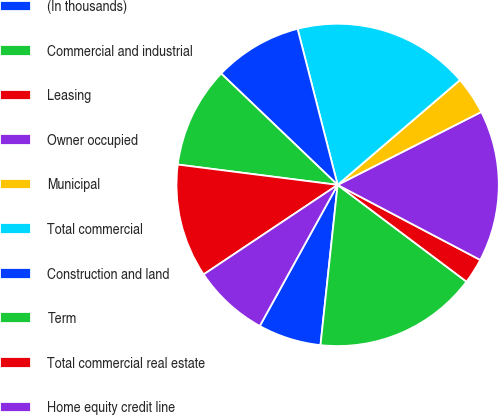Convert chart to OTSL. <chart><loc_0><loc_0><loc_500><loc_500><pie_chart><fcel>(In thousands)<fcel>Commercial and industrial<fcel>Leasing<fcel>Owner occupied<fcel>Municipal<fcel>Total commercial<fcel>Construction and land<fcel>Term<fcel>Total commercial real estate<fcel>Home equity credit line<nl><fcel>6.33%<fcel>16.45%<fcel>2.54%<fcel>15.19%<fcel>3.8%<fcel>17.72%<fcel>8.86%<fcel>10.13%<fcel>11.39%<fcel>7.6%<nl></chart> 